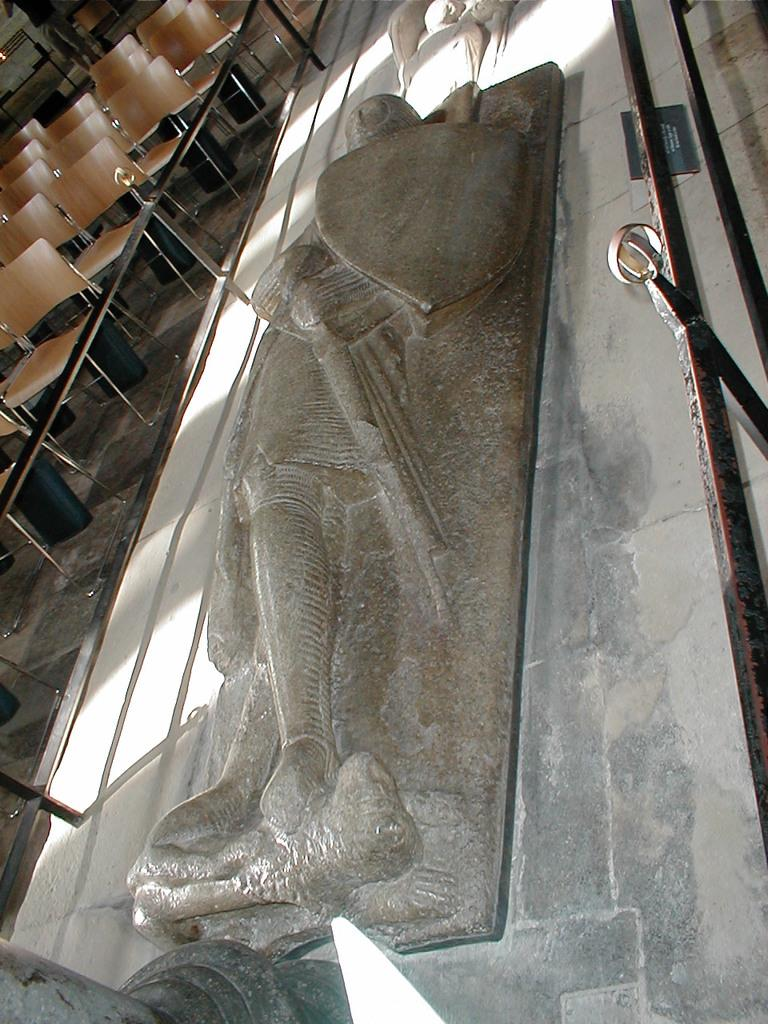What is the main subject in the image? There is a statue in the image. Where is the statue located? The statue is on a platform. What is beside the statue? There is a fence and chairs beside the statue. What direction is the thunder coming from in the image? There is no thunder present in the image. 